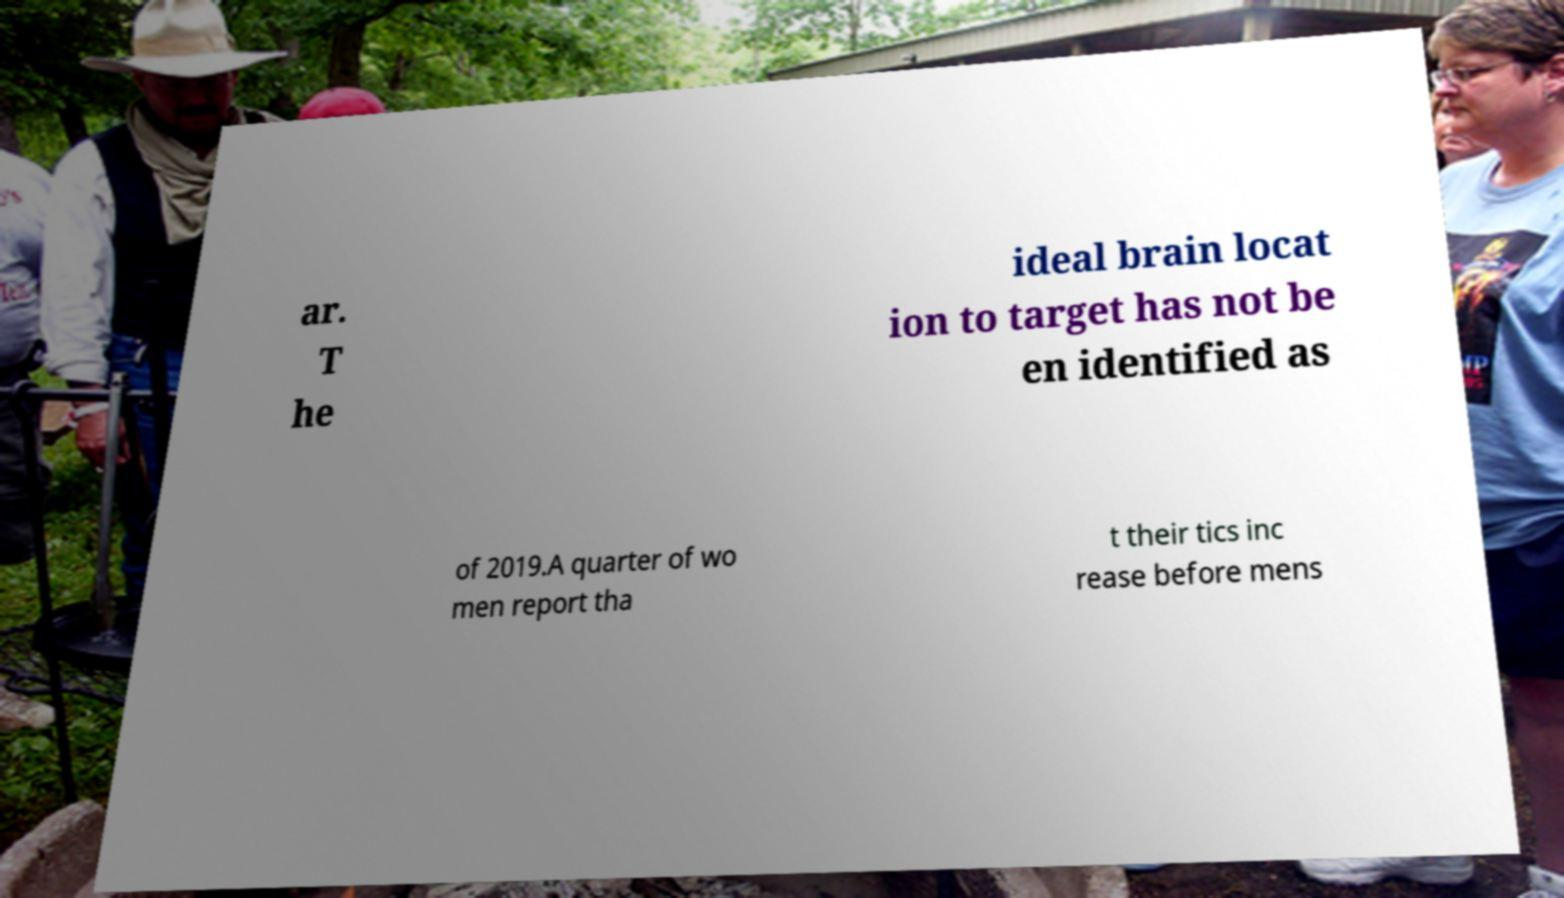Please read and relay the text visible in this image. What does it say? ar. T he ideal brain locat ion to target has not be en identified as of 2019.A quarter of wo men report tha t their tics inc rease before mens 